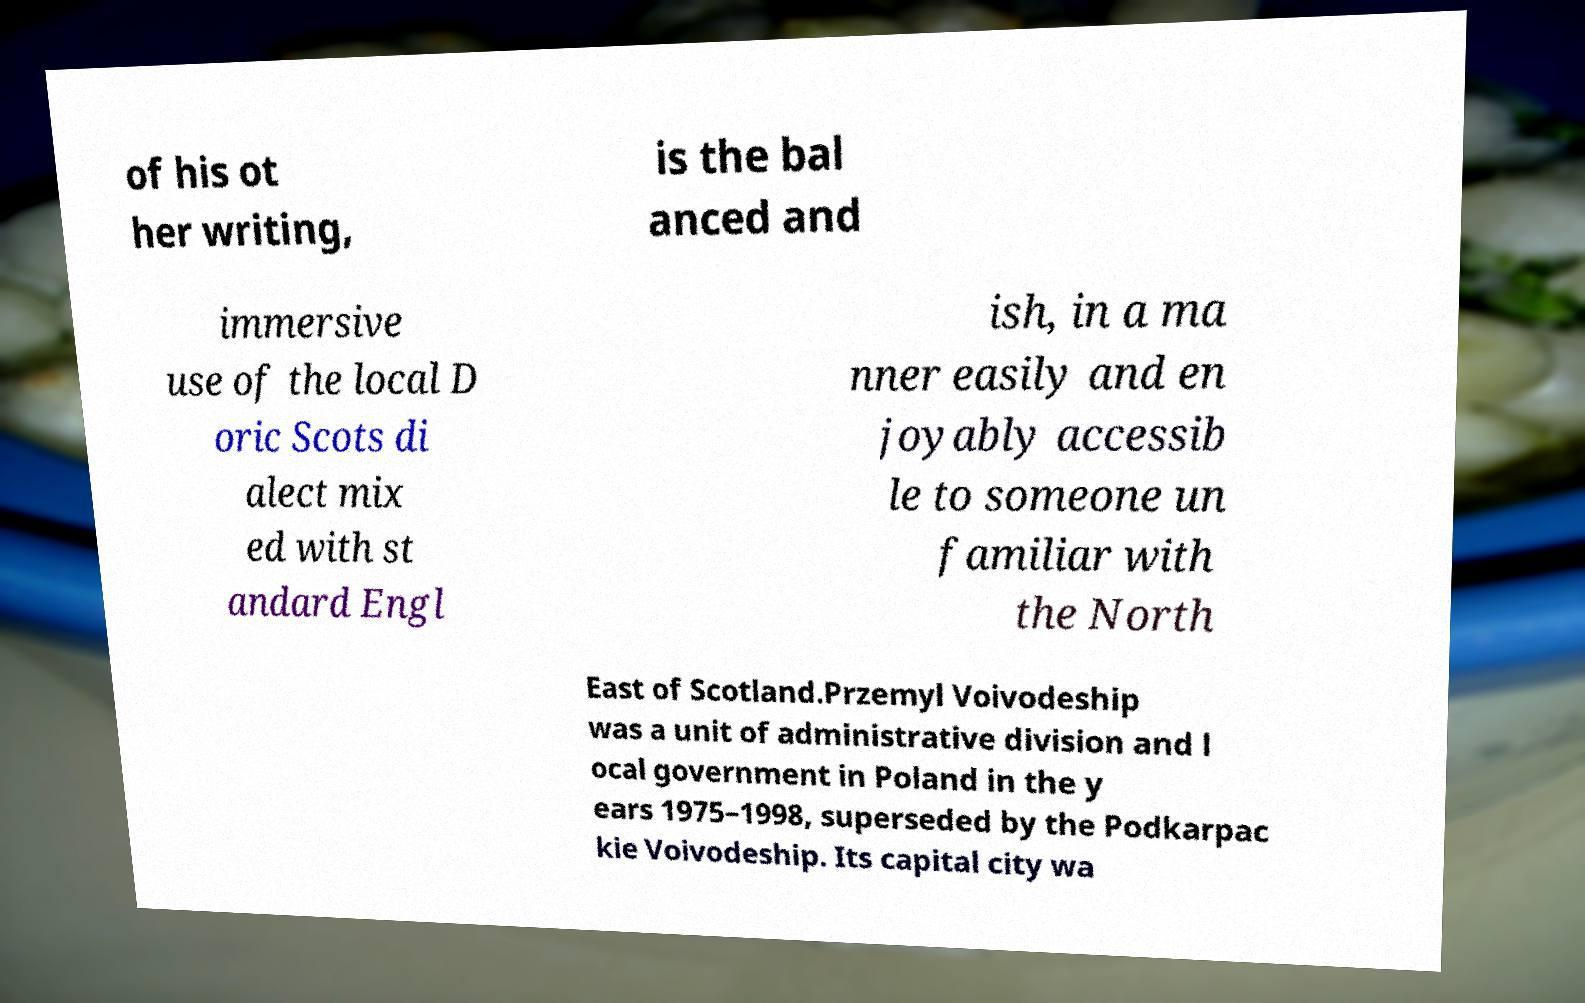For documentation purposes, I need the text within this image transcribed. Could you provide that? of his ot her writing, is the bal anced and immersive use of the local D oric Scots di alect mix ed with st andard Engl ish, in a ma nner easily and en joyably accessib le to someone un familiar with the North East of Scotland.Przemyl Voivodeship was a unit of administrative division and l ocal government in Poland in the y ears 1975–1998, superseded by the Podkarpac kie Voivodeship. Its capital city wa 